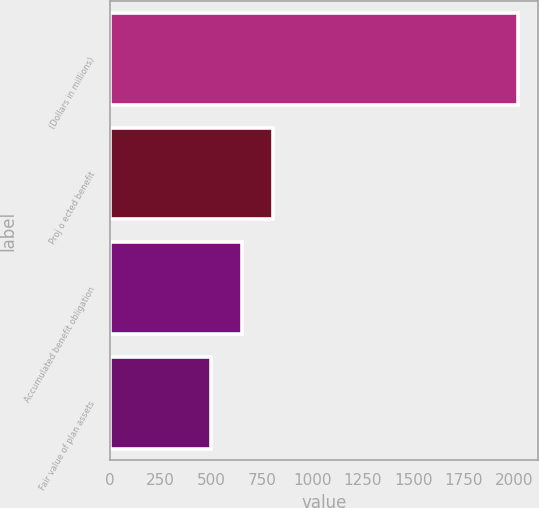Convert chart. <chart><loc_0><loc_0><loc_500><loc_500><bar_chart><fcel>(Dollars in millions)<fcel>Proj o ected benefit<fcel>Accumulated benefit obligation<fcel>Fair value of plan assets<nl><fcel>2015<fcel>803.8<fcel>652.4<fcel>501<nl></chart> 